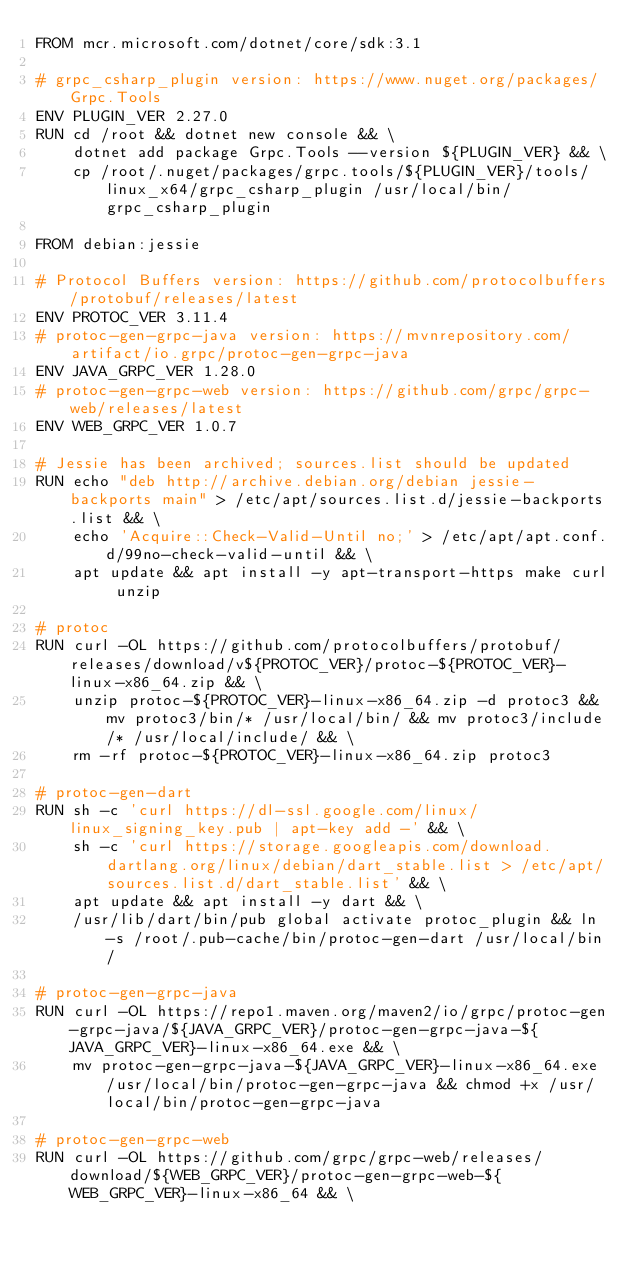<code> <loc_0><loc_0><loc_500><loc_500><_Dockerfile_>FROM mcr.microsoft.com/dotnet/core/sdk:3.1

# grpc_csharp_plugin version: https://www.nuget.org/packages/Grpc.Tools
ENV PLUGIN_VER 2.27.0
RUN cd /root && dotnet new console && \
	dotnet add package Grpc.Tools --version ${PLUGIN_VER} && \
	cp /root/.nuget/packages/grpc.tools/${PLUGIN_VER}/tools/linux_x64/grpc_csharp_plugin /usr/local/bin/grpc_csharp_plugin

FROM debian:jessie

# Protocol Buffers version: https://github.com/protocolbuffers/protobuf/releases/latest
ENV PROTOC_VER 3.11.4
# protoc-gen-grpc-java version: https://mvnrepository.com/artifact/io.grpc/protoc-gen-grpc-java
ENV JAVA_GRPC_VER 1.28.0
# protoc-gen-grpc-web version: https://github.com/grpc/grpc-web/releases/latest
ENV WEB_GRPC_VER 1.0.7

# Jessie has been archived; sources.list should be updated
RUN echo "deb http://archive.debian.org/debian jessie-backports main" > /etc/apt/sources.list.d/jessie-backports.list && \
	echo 'Acquire::Check-Valid-Until no;' > /etc/apt/apt.conf.d/99no-check-valid-until && \
	apt update && apt install -y apt-transport-https make curl unzip

# protoc
RUN curl -OL https://github.com/protocolbuffers/protobuf/releases/download/v${PROTOC_VER}/protoc-${PROTOC_VER}-linux-x86_64.zip && \
	unzip protoc-${PROTOC_VER}-linux-x86_64.zip -d protoc3 && mv protoc3/bin/* /usr/local/bin/ && mv protoc3/include/* /usr/local/include/ && \
	rm -rf protoc-${PROTOC_VER}-linux-x86_64.zip protoc3

# protoc-gen-dart
RUN sh -c 'curl https://dl-ssl.google.com/linux/linux_signing_key.pub | apt-key add -' && \
	sh -c 'curl https://storage.googleapis.com/download.dartlang.org/linux/debian/dart_stable.list > /etc/apt/sources.list.d/dart_stable.list' && \
	apt update && apt install -y dart && \
	/usr/lib/dart/bin/pub global activate protoc_plugin && ln -s /root/.pub-cache/bin/protoc-gen-dart /usr/local/bin/

# protoc-gen-grpc-java
RUN curl -OL https://repo1.maven.org/maven2/io/grpc/protoc-gen-grpc-java/${JAVA_GRPC_VER}/protoc-gen-grpc-java-${JAVA_GRPC_VER}-linux-x86_64.exe && \
	mv protoc-gen-grpc-java-${JAVA_GRPC_VER}-linux-x86_64.exe /usr/local/bin/protoc-gen-grpc-java && chmod +x /usr/local/bin/protoc-gen-grpc-java

# protoc-gen-grpc-web
RUN curl -OL https://github.com/grpc/grpc-web/releases/download/${WEB_GRPC_VER}/protoc-gen-grpc-web-${WEB_GRPC_VER}-linux-x86_64 && \</code> 